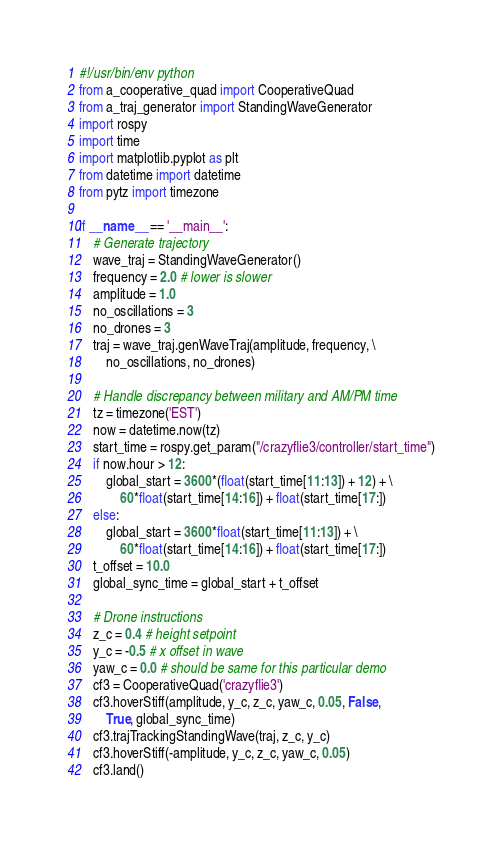Convert code to text. <code><loc_0><loc_0><loc_500><loc_500><_Python_>#!/usr/bin/env python
from a_cooperative_quad import CooperativeQuad
from a_traj_generator import StandingWaveGenerator
import rospy
import time
import matplotlib.pyplot as plt
from datetime import datetime
from pytz import timezone

if __name__ == '__main__':
    # Generate trajectory
    wave_traj = StandingWaveGenerator()
    frequency = 2.0 # lower is slower
    amplitude = 1.0
    no_oscillations = 3
    no_drones = 3
    traj = wave_traj.genWaveTraj(amplitude, frequency, \
        no_oscillations, no_drones)

    # Handle discrepancy between military and AM/PM time
    tz = timezone('EST')
    now = datetime.now(tz)
    start_time = rospy.get_param("/crazyflie3/controller/start_time")
    if now.hour > 12:
        global_start = 3600*(float(start_time[11:13]) + 12) + \
            60*float(start_time[14:16]) + float(start_time[17:])
    else:
        global_start = 3600*float(start_time[11:13]) + \
            60*float(start_time[14:16]) + float(start_time[17:])
    t_offset = 10.0
    global_sync_time = global_start + t_offset 

    # Drone instructions
    z_c = 0.4 # height setpoint
    y_c = -0.5 # x offset in wave
    yaw_c = 0.0 # should be same for this particular demo
    cf3 = CooperativeQuad('crazyflie3')
    cf3.hoverStiff(amplitude, y_c, z_c, yaw_c, 0.05, False,
        True, global_sync_time)
    cf3.trajTrackingStandingWave(traj, z_c, y_c)
    cf3.hoverStiff(-amplitude, y_c, z_c, yaw_c, 0.05)
    cf3.land()</code> 